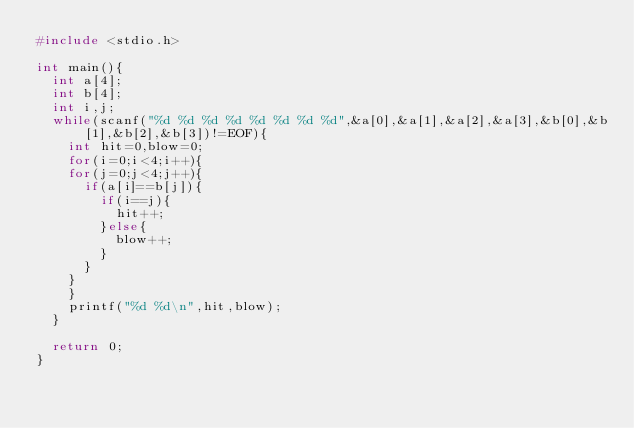<code> <loc_0><loc_0><loc_500><loc_500><_C_>#include <stdio.h>

int main(){
	int a[4];
	int b[4];
	int i,j;
	while(scanf("%d %d %d %d %d %d %d %d",&a[0],&a[1],&a[2],&a[3],&b[0],&b[1],&b[2],&b[3])!=EOF){
		int hit=0,blow=0;
		for(i=0;i<4;i++){
		for(j=0;j<4;j++){
			if(a[i]==b[j]){
				if(i==j){
					hit++;
				}else{
					blow++;
				}
			}
		}
		}
		printf("%d %d\n",hit,blow);
	}
	
	return 0;
}</code> 